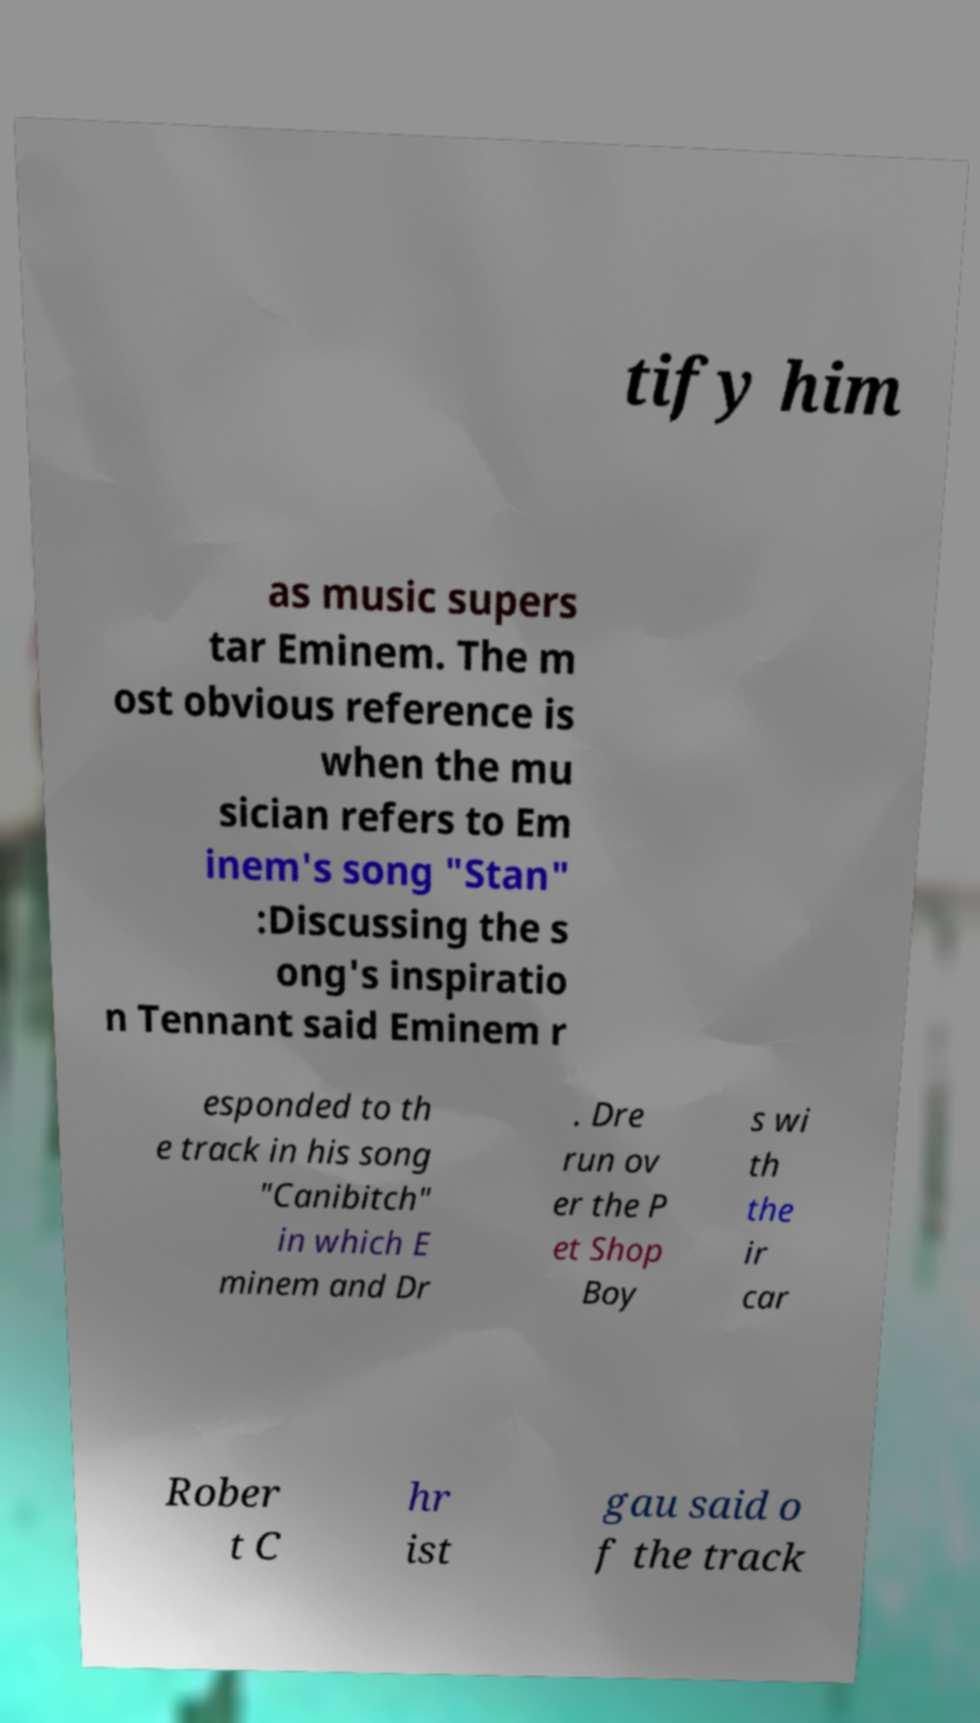Please identify and transcribe the text found in this image. tify him as music supers tar Eminem. The m ost obvious reference is when the mu sician refers to Em inem's song "Stan" :Discussing the s ong's inspiratio n Tennant said Eminem r esponded to th e track in his song "Canibitch" in which E minem and Dr . Dre run ov er the P et Shop Boy s wi th the ir car Rober t C hr ist gau said o f the track 